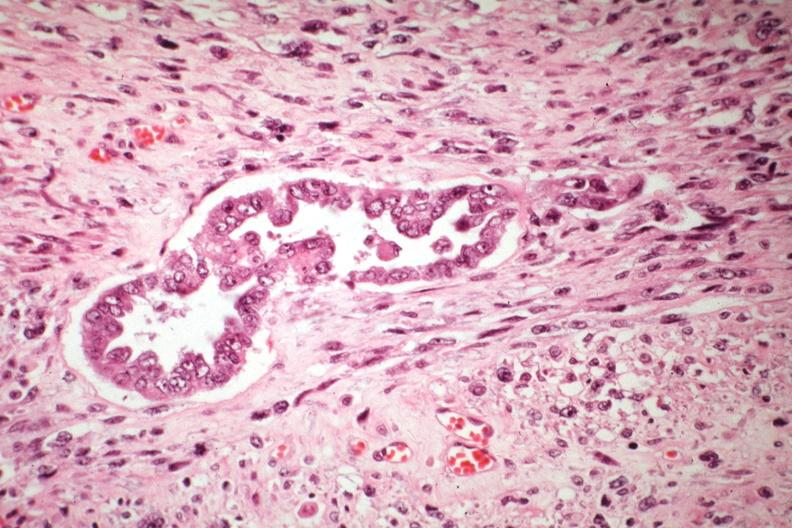what does this image show?
Answer the question using a single word or phrase. Malignant gland and stoma well shown 